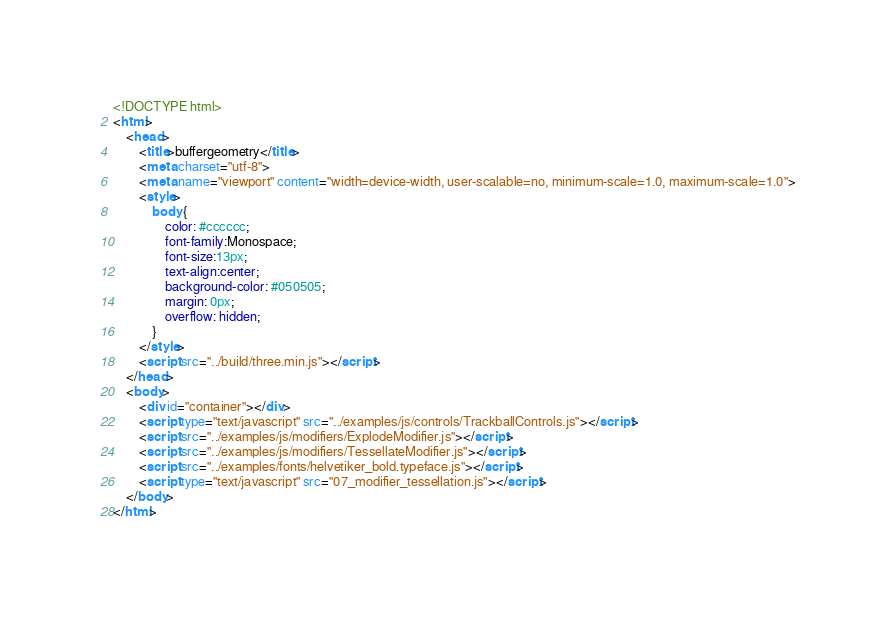<code> <loc_0><loc_0><loc_500><loc_500><_HTML_><!DOCTYPE html>
<html>
	<head>
		<title>buffergeometry</title>
		<meta charset="utf-8">
		<meta name="viewport" content="width=device-width, user-scalable=no, minimum-scale=1.0, maximum-scale=1.0">
		<style>
			body {
				color: #cccccc;
				font-family:Monospace;
				font-size:13px;
				text-align:center;
				background-color: #050505;
				margin: 0px;
				overflow: hidden;
			}
		</style>
		<script src="../build/three.min.js"></script>
	</head>
	<body>
		<div id="container"></div>
		<script type="text/javascript" src="../examples/js/controls/TrackballControls.js"></script>
		<script src="../examples/js/modifiers/ExplodeModifier.js"></script>
		<script src="../examples/js/modifiers/TessellateModifier.js"></script>
		<script src="../examples/fonts/helvetiker_bold.typeface.js"></script>
		<script type="text/javascript" src="07_modifier_tessellation.js"></script>
	</body>
</html>
</code> 